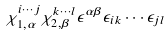<formula> <loc_0><loc_0><loc_500><loc_500>\chi ^ { i \cdots j } _ { 1 , \alpha } \chi ^ { k \cdots l } _ { 2 , \beta } \epsilon ^ { \alpha \beta } \epsilon _ { i k } \cdots \epsilon _ { j l }</formula> 